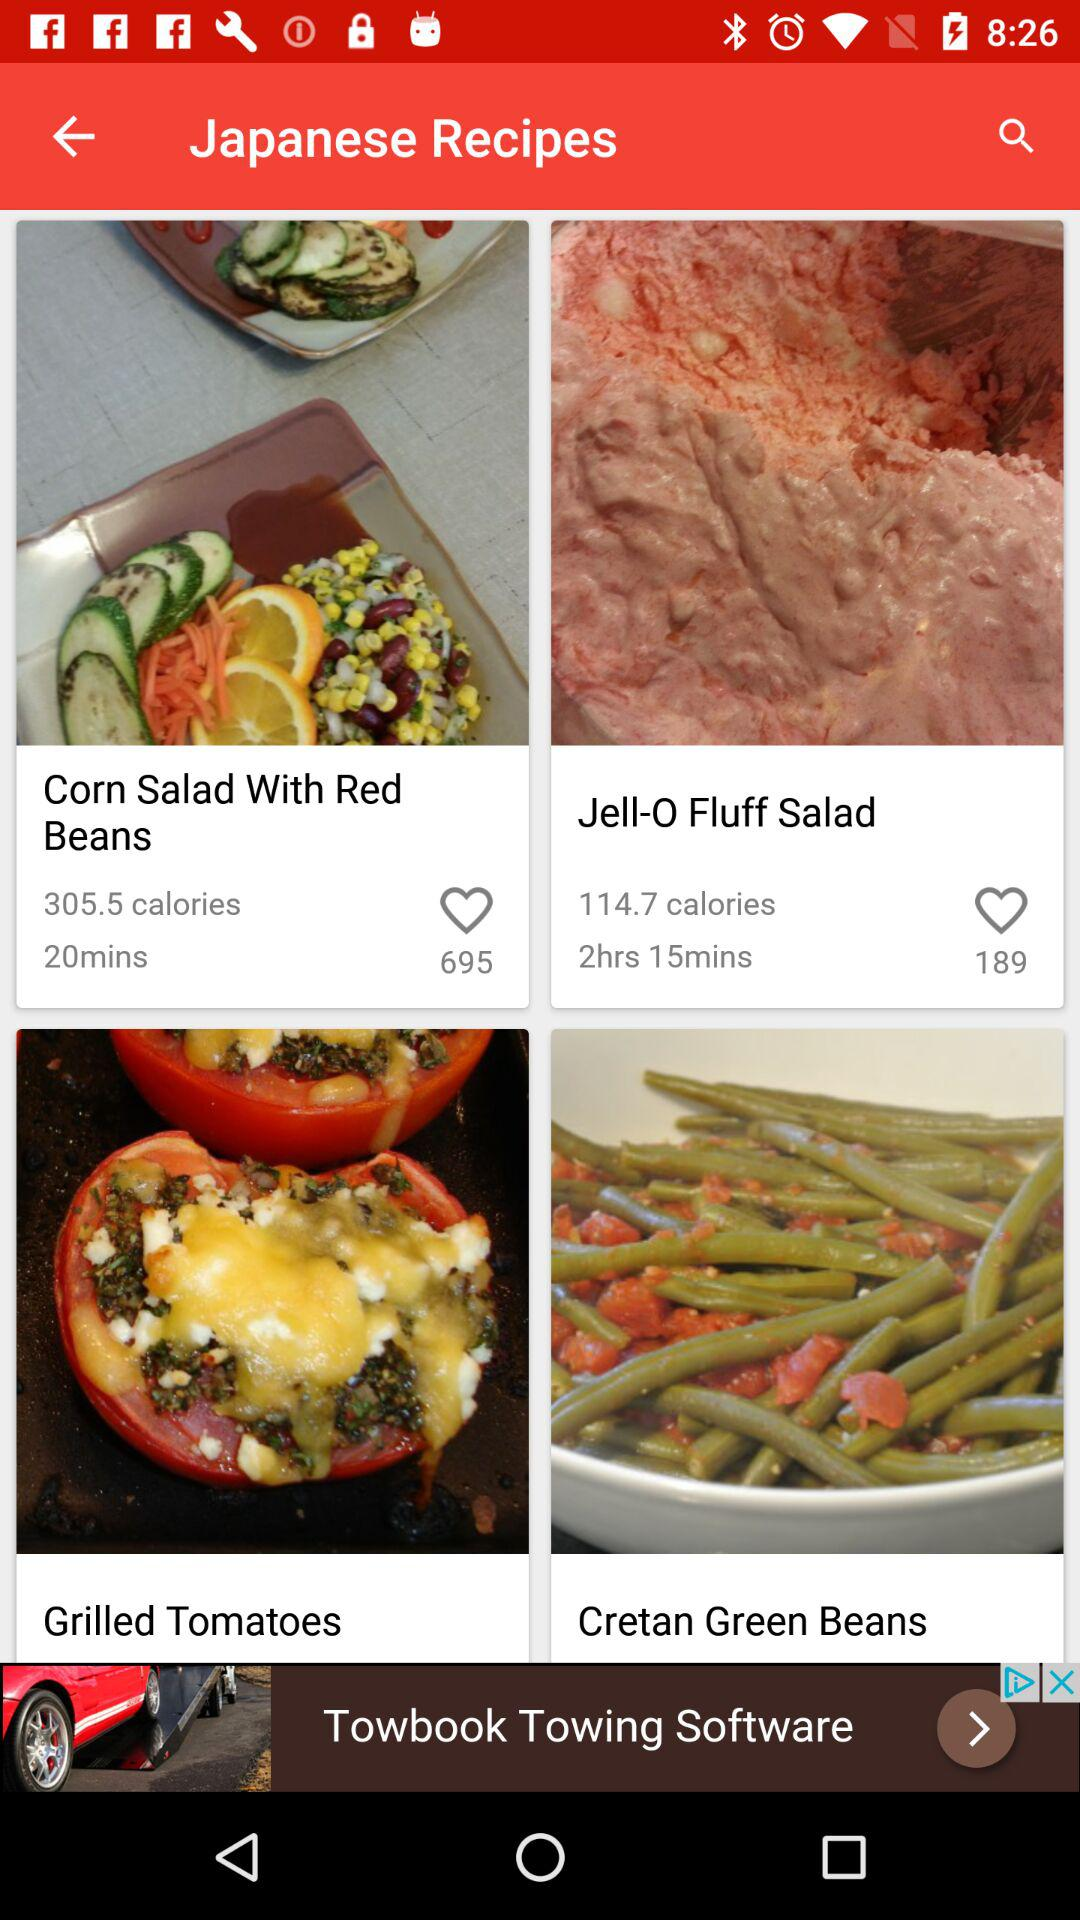Which recipe has more calories, Corn Salad With Red Beans or Jell-O Fluff Salad?
Answer the question using a single word or phrase. Corn Salad With Red Beans 